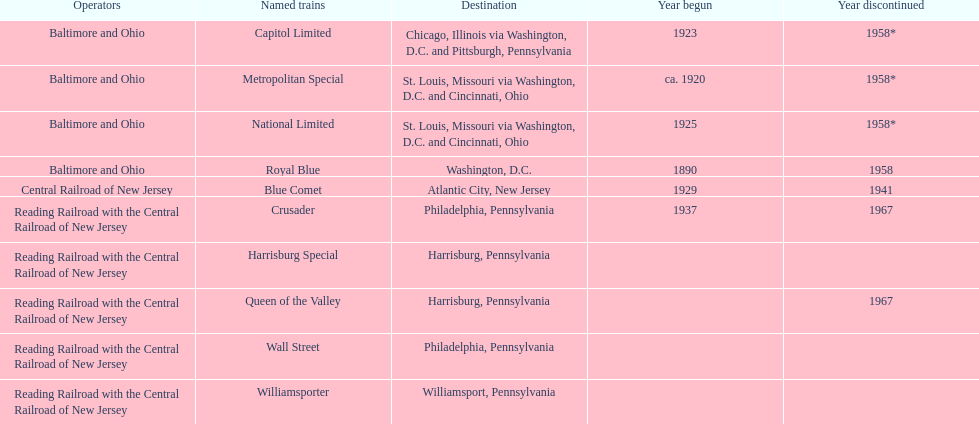Which train ran for the longest time? Royal Blue. 